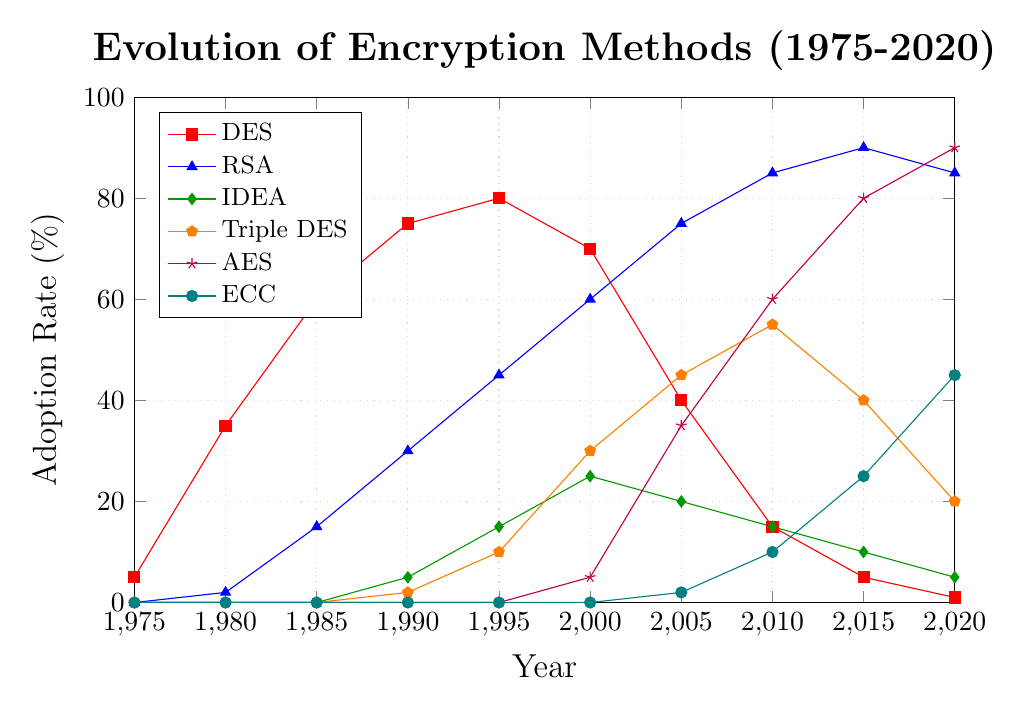What's the trend for DES encryption adoption between 1975 and 2020? The trend shows that DES adoption started at 5% in 1975, peaked at 80% in 1995, and then declined steadily to 1% by 2020. The peak adoption was before a steady decline, likely due to the emergence of newer encryption methods.
Answer: It peaked and then declined When did RSA overtake DES in adoption rates? RSA overtook DES in adoption rates after 2000. We see in the figure that in 2005, the adoption rate of RSA was 75% compared to DES's 40%. Looking further, in 2000 DES had 70% while RSA had just 60%, indicating the overtaking happened between these years.
Answer: After 2000 Which encryption method had the highest adoption rate in 2020, and what was the rate? In 2020, the encryption method AES had the highest adoption rate at 90%. The figure clearly shows the purple line representing AES at the topmost level in 2020.
Answer: AES, 90% Compare the adoption rates of IDEA and Triple DES in 2000. In 2000, IDEA had an adoption rate of 25%, and Triple DES had a rate of 30%. By comparing the values from the figure, we see the green line (IDEA) is slightly below the orange line (Triple DES).
Answer: IDEA: 25%, Triple DES: 30% What is the most significant drop in adoption rate for any encryption method, and between which years does it occur? The most significant drop in adoption rate occurs for DES between 2000 and 2005. DES drops from 70% in 2000 to 40% in 2005, showing a 30% decrease. This can be observed by the steep decline in the red line in the figure.
Answer: DES, between 2000 and 2005 What was the average adoption rate of ECC from 2005 to 2020? From the figure, ECC adoption rates are 2% (2005), 10% (2010), 25% (2015), and 45% (2020). Sum these rates: 2 + 10 + 25 + 45 = 82. There are 4 data points, so the average is 82 / 4 = 20.5%.
Answer: 20.5% How did the adoption rate of AES change from its initial introduction until 2020? AES adoption started at 5% in 2000, increased to 35% in 2005, 60% in 2010, 80% in 2015, and reached 90% in 2020. The purple line in the figure consistently moves upward from 2000 to 2020, indicating a steady and sharp increase.
Answer: It steadily increased Which encryption method's adoption rate never fell below its previous recorded year? RSA's adoption rate consistently increases or stays the same every period. Reviewing the blue line in the figure, we do not see any downward trend, indicating a consistent or increasing adoption.
Answer: RSA How much did ECC adoption increase from 2005 to 2020? ECC adoption increased from 2% in 2005 to 45% in 2020. The increase is calculated as 45% - 2% = 43%. This change is seen in the teal line moving upward over these years.
Answer: 43% What encryption method had the second-highest adoption rate in 2010, and what was the rate? In 2010, the encryption method Triple DES had the second-highest adoption rate at 55%, as indicated by the orange line being just below the highest (AES) at that year.
Answer: Triple DES, 55% 